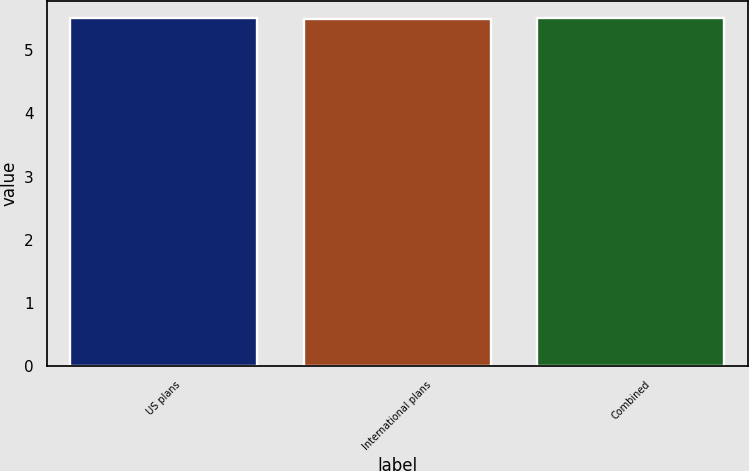<chart> <loc_0><loc_0><loc_500><loc_500><bar_chart><fcel>US plans<fcel>International plans<fcel>Combined<nl><fcel>5.5<fcel>5.49<fcel>5.5<nl></chart> 